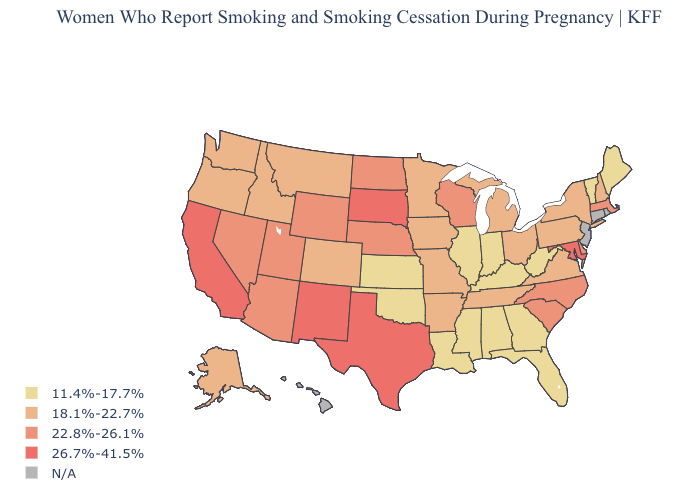What is the highest value in states that border Florida?
Give a very brief answer. 11.4%-17.7%. Which states have the highest value in the USA?
Write a very short answer. California, Maryland, New Mexico, South Dakota, Texas. Does Kentucky have the lowest value in the USA?
Quick response, please. Yes. What is the value of Idaho?
Answer briefly. 18.1%-22.7%. Is the legend a continuous bar?
Be succinct. No. Which states have the lowest value in the USA?
Short answer required. Alabama, Florida, Georgia, Illinois, Indiana, Kansas, Kentucky, Louisiana, Maine, Mississippi, Oklahoma, Vermont, West Virginia. Does South Dakota have the lowest value in the MidWest?
Short answer required. No. What is the highest value in states that border Florida?
Be succinct. 11.4%-17.7%. What is the highest value in the USA?
Short answer required. 26.7%-41.5%. Does the map have missing data?
Write a very short answer. Yes. Is the legend a continuous bar?
Be succinct. No. How many symbols are there in the legend?
Quick response, please. 5. Name the states that have a value in the range 26.7%-41.5%?
Short answer required. California, Maryland, New Mexico, South Dakota, Texas. Name the states that have a value in the range 26.7%-41.5%?
Quick response, please. California, Maryland, New Mexico, South Dakota, Texas. 